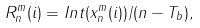<formula> <loc_0><loc_0><loc_500><loc_500>R ^ { m } _ { n } ( i ) = I n t ( x ^ { m } _ { n } ( i ) ) / ( n - T _ { b } ) ,</formula> 